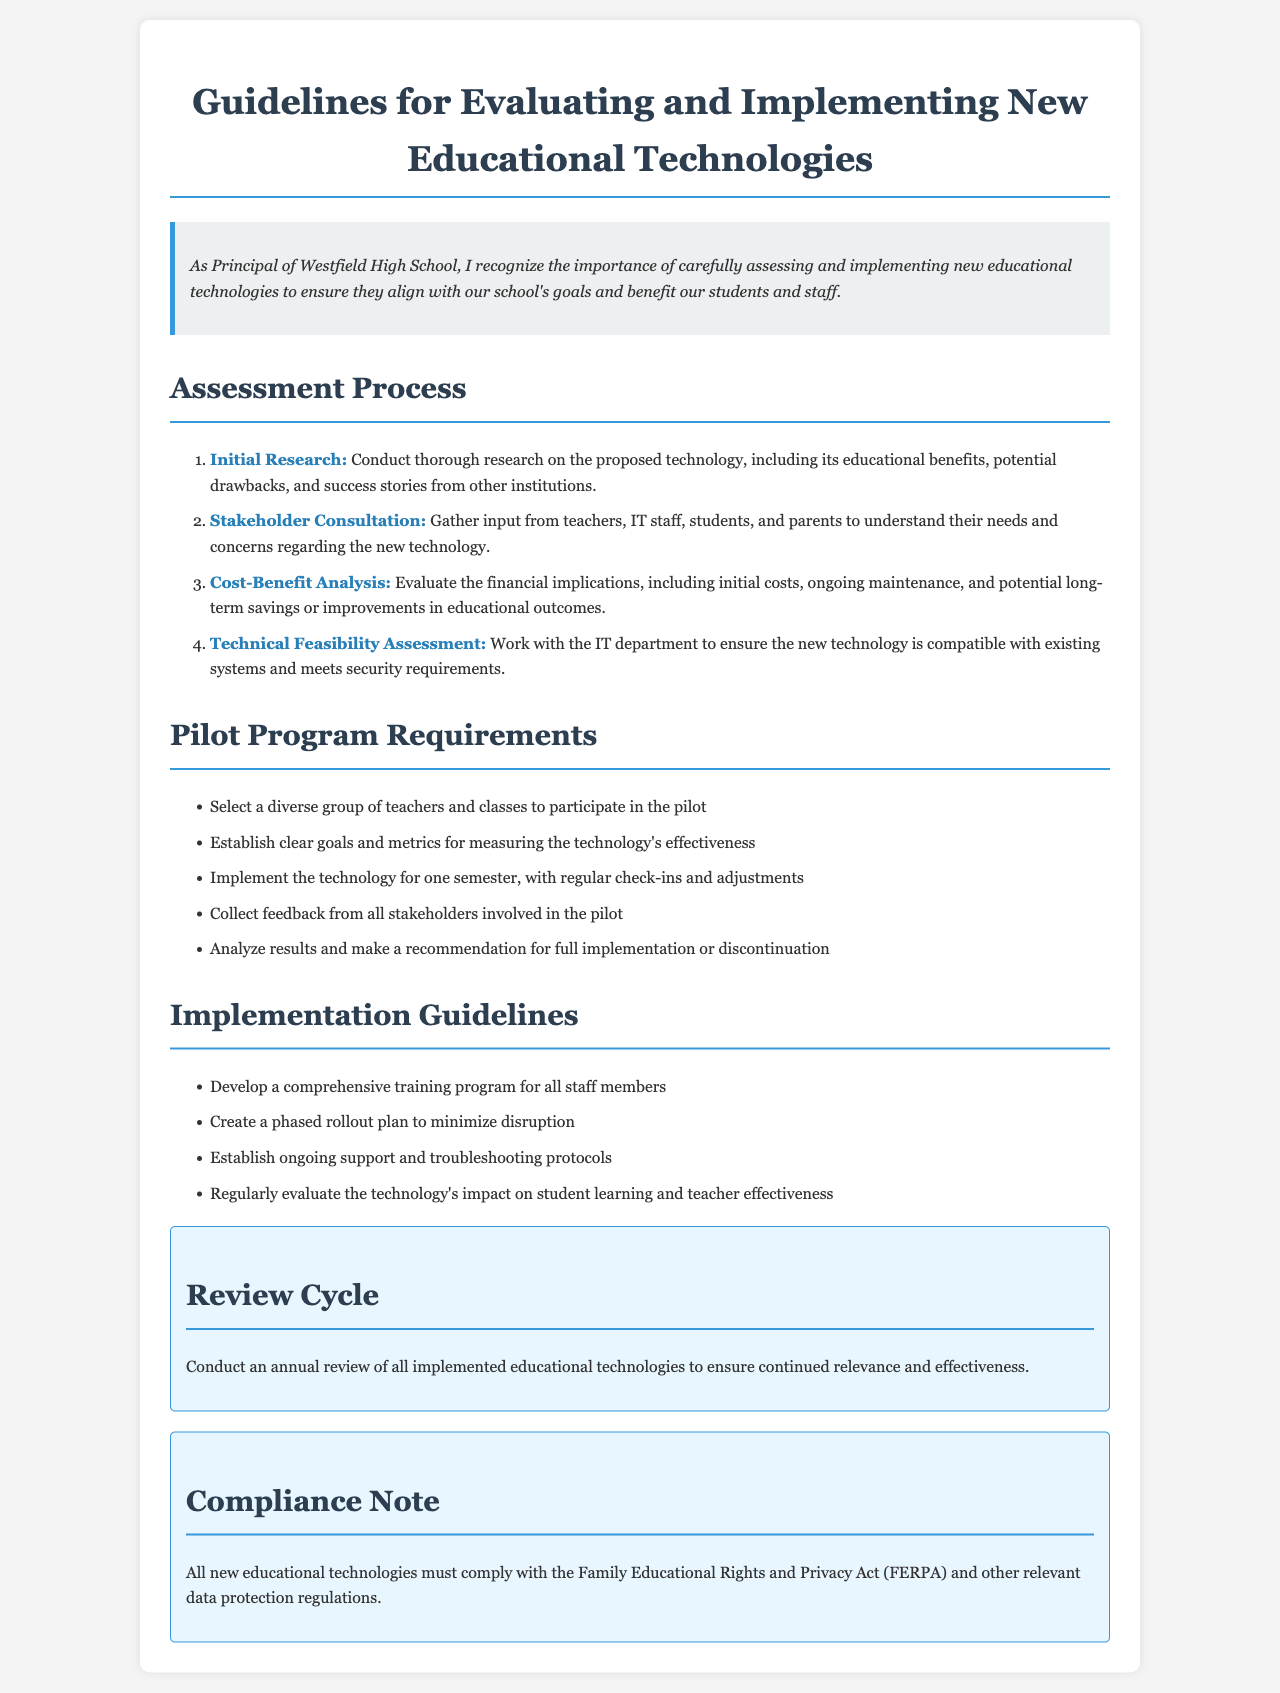What is the title of the document? The title of the document is clearly mentioned at the top of the rendered content.
Answer: Guidelines for Evaluating and Implementing New Educational Technologies Who is responsible for the policy? The introductory paragraph specifies the role of the individual who recognizes the importance of the policy.
Answer: Principal of Westfield High School What is the first step of the assessment process? The document outlines a multi-step assessment process and lists the steps in order.
Answer: Initial Research How long should the pilot program be implemented? The pilot program requirements section explicitly states the duration for the pilot testing of technology.
Answer: One semester Which act must new educational technologies comply with? The compliance note at the end of the document clearly identifies which act governs privacy and data protection.
Answer: Family Educational Rights and Privacy Act (FERPA) What type of analysis is required in the assessment process? The assessment process includes evaluating financial implications as part of its steps.
Answer: Cost-Benefit Analysis What is the purpose of the review cycle? This section is specifically about maintaining the relevance of implemented technologies, indicating its purpose.
Answer: Annual review What must be established for the pilot program? The requirements section highlights what should be set up for evaluating the technology during the pilot phase.
Answer: Clear goals and metrics 